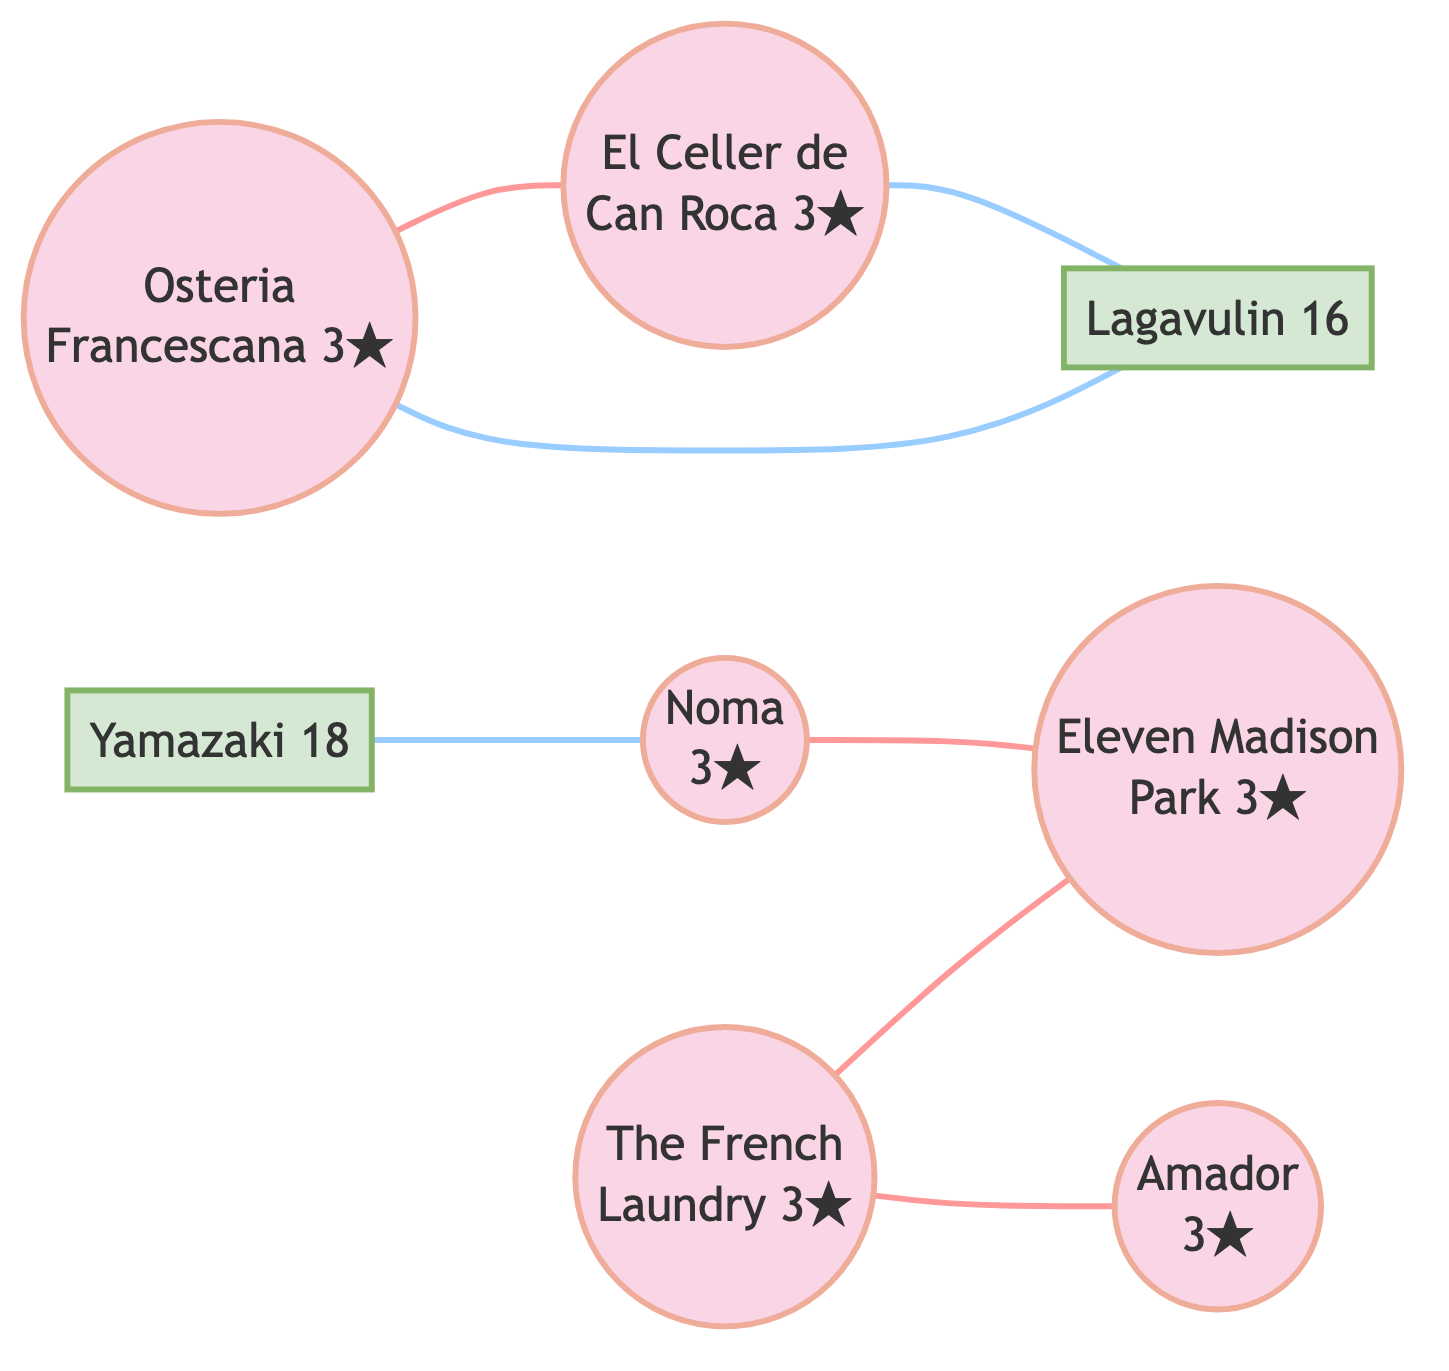What is the highest Michelin rating among the restaurants? The highest Michelin rating in the diagram is found by examining each restaurant's details. All listed restaurants have a rating of 3 stars, which is the maximum.
Answer: 3 How many restaurants are connected to Yamazaki Whisky? To find the number of restaurants connected to Yamazaki Whisky, I need to look at the edges that include Yamazaki. It connects to one restaurant: Noma.
Answer: 1 Which restaurant is connected to El Celler de Can Roca through inspiration? I check the edges for any connections with El Celler de Can Roca. It is connected to Osteria Francescana by the relation of inspiration.
Answer: Osteria Francescana Which whisky is associated with The French Laundry through chef training? The relationship for chef training indicates the direct link to Amador. Therefore, I consider the edges until I find the association. The connection is direct from The French Laundry.
Answer: Amador How many total edges are present in the diagram? To determine the total edges, I count all the relationships between the nodes. There are seven edges listed in the data, indicating the various connections.
Answer: 7 Which cuisine does the restaurant Noma serve? The diagram explicitly states the type of cuisine each restaurant serves. Noma is noted for its Nordic cuisine.
Answer: Nordic Is there any whisky paired with Osteria Francescana? I look at the edges related to Osteria Francescana and confirm that Lagavulin is specifically mentioned as the pairing whisky.
Answer: Lagavulin Which restaurant collaborates with Eleven Madison Park? I check the edges connected to Eleven Madison Park and find a collaboration noted with Noma.
Answer: Noma 